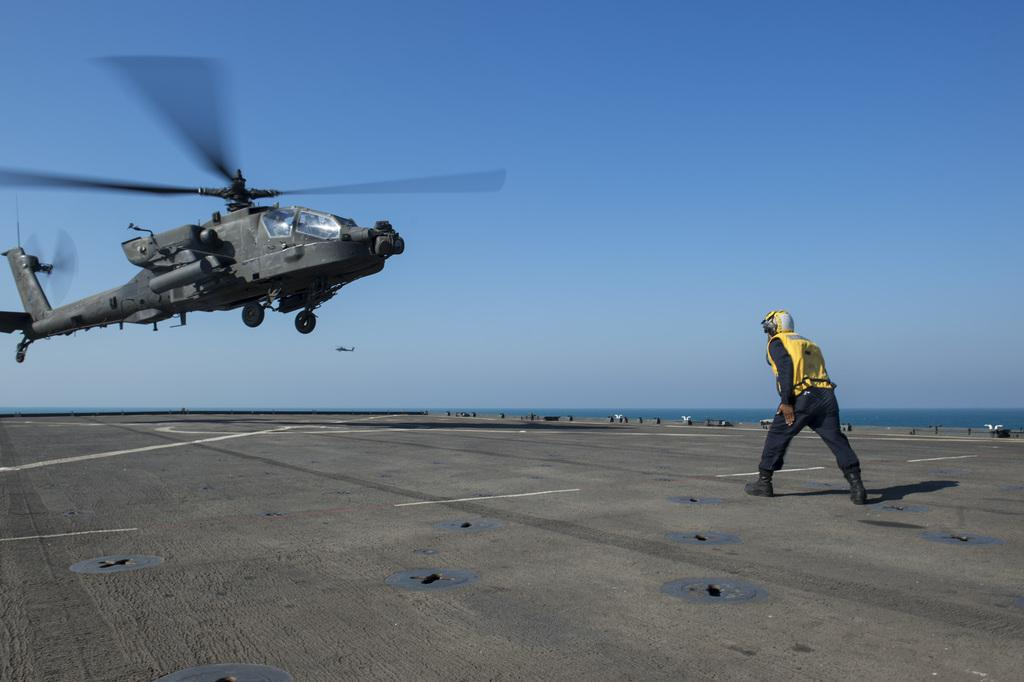What is the main subject in the foreground of the image? There is a man in the foreground of the image. Where is the man located in the image? The man is on the road. What can be seen in the air on the left side of the image? There is a helicopter (copter) in the air on the left side of the image. What is visible in the background of the image? There is sky and water visible in the background of the image. How many helicopters can be seen in the image? There are two helicopters visible in the image. What type of metal is the word "pear" made of in the image? There is no word "pear" made of metal present in the image. 